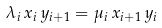<formula> <loc_0><loc_0><loc_500><loc_500>\lambda _ { i } \, x _ { i } \, y _ { i + 1 } = \mu _ { i } \, x _ { i + 1 } \, y _ { i }</formula> 